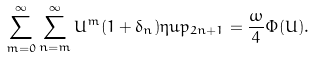<formula> <loc_0><loc_0><loc_500><loc_500>\sum ^ { \infty } _ { m = 0 } \sum ^ { \infty } _ { n = m } U ^ { m } ( 1 + \delta _ { n } ) \eta u p _ { 2 n + 1 } = \frac { \omega } { 4 } \Phi ( U ) .</formula> 